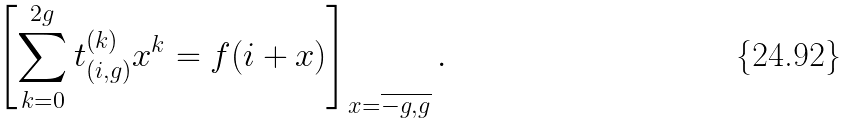<formula> <loc_0><loc_0><loc_500><loc_500>\left [ \sum _ { k = 0 } ^ { 2 g } t _ { ( i , g ) } ^ { ( k ) } x ^ { k } = f ( i + x ) \right ] _ { x = \overline { - g , g } } .</formula> 